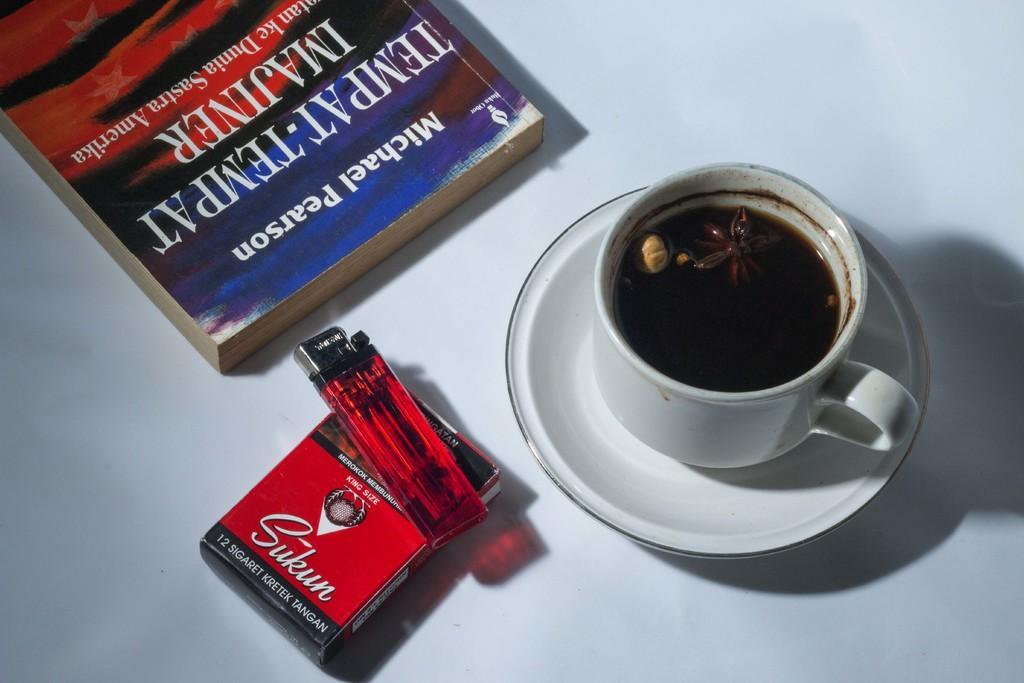Could you give a brief overview of what you see in this image? In this image we can see a cup of tea, a pack of cigarettes, a lighter and a book placed on a table. 